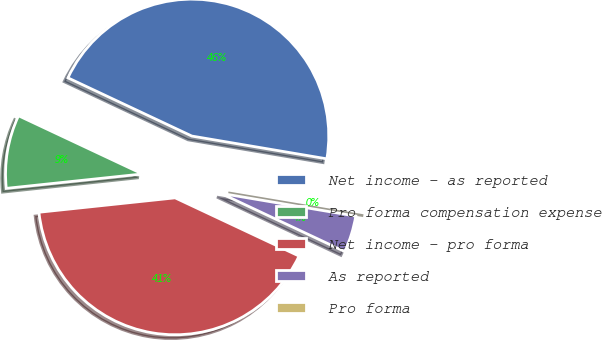Convert chart to OTSL. <chart><loc_0><loc_0><loc_500><loc_500><pie_chart><fcel>Net income - as reported<fcel>Pro forma compensation expense<fcel>Net income - pro forma<fcel>As reported<fcel>Pro forma<nl><fcel>45.67%<fcel>8.67%<fcel>41.33%<fcel>4.33%<fcel>0.0%<nl></chart> 